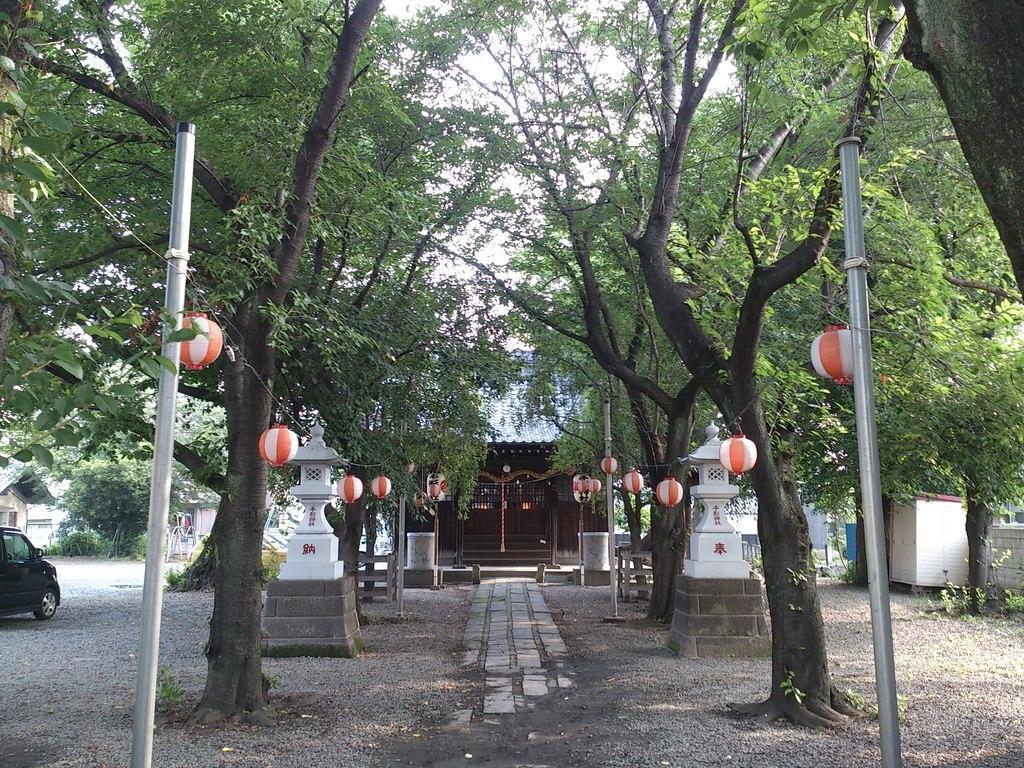Could you give a brief overview of what you see in this image? In this image there is a house. Before it there is a path. On both sides of the path there are pillars on the land having few poles which are connected with wire having few balloons attached to it. Left side there is a car on the land. Behind it there are few trees and buildings. Right side there is a wall. Before it there are few trees on the land. 